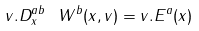<formula> <loc_0><loc_0><loc_500><loc_500>v . D _ { x } ^ { a b } \ W ^ { b } ( x , { v } ) = { v } . { E } ^ { a } ( x )</formula> 